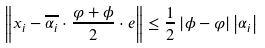Convert formula to latex. <formula><loc_0><loc_0><loc_500><loc_500>\left \| x _ { i } - \overline { \alpha _ { i } } \cdot \frac { \varphi + \phi } { 2 } \cdot e \right \| \leq \frac { 1 } { 2 } \left | \phi - \varphi \right | \left | \alpha _ { i } \right |</formula> 